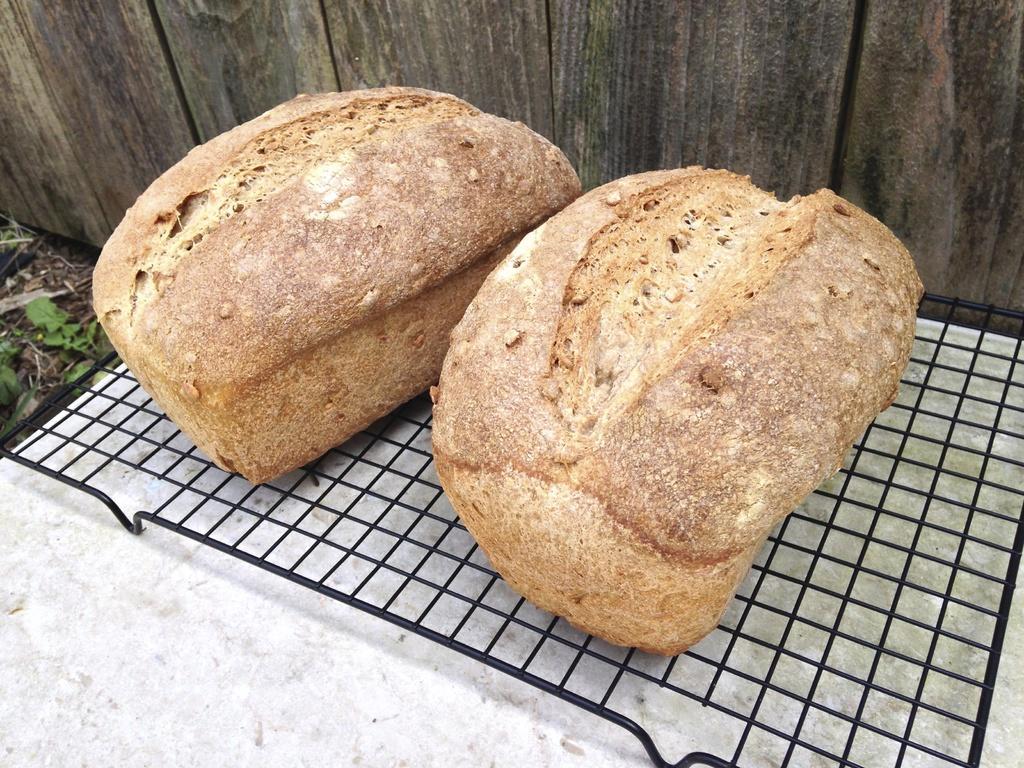In one or two sentences, can you explain what this image depicts? In the center of the image we can see a loaves of bread on the grill. In The background there is a wall. 